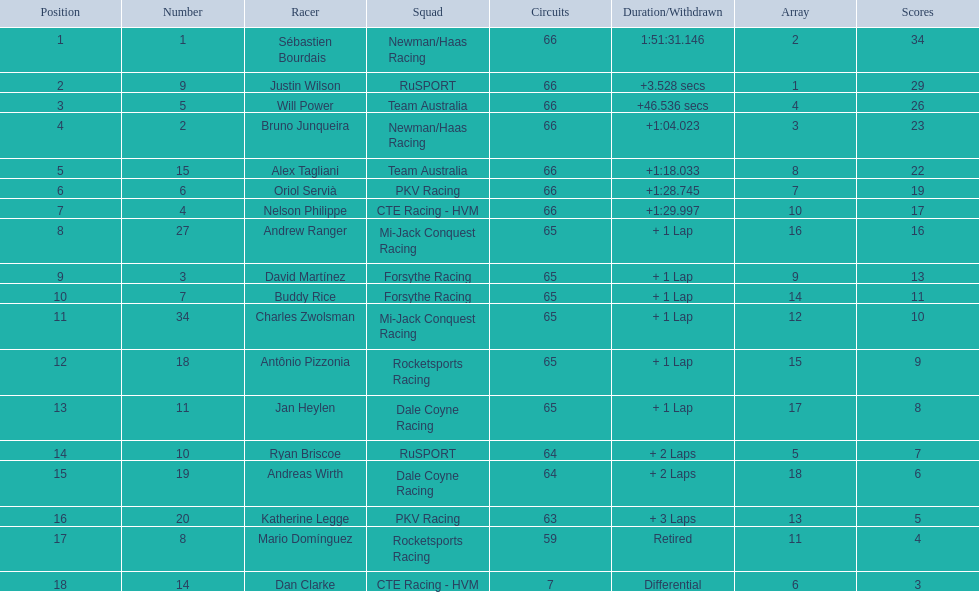Who completed the race right after rice, who was 10th? Charles Zwolsman. 